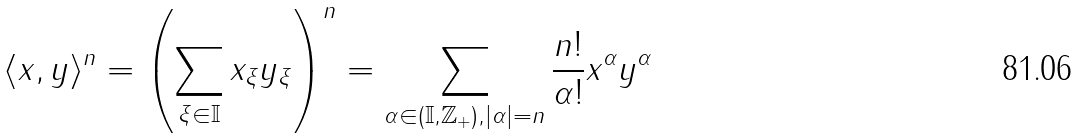<formula> <loc_0><loc_0><loc_500><loc_500>\langle x , y \rangle ^ { n } = \left ( \sum _ { \xi \in \mathbb { I } } x _ { \xi } y _ { \xi } \right ) ^ { n } = \sum _ { \alpha \in ( \mathbb { I } , \mathbb { Z } _ { + } ) , | \alpha | = n } \frac { n ! } { \alpha ! } x ^ { \alpha } y ^ { \alpha }</formula> 